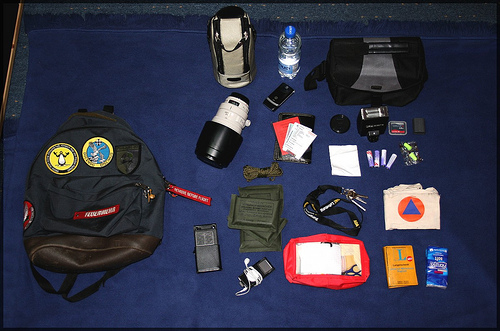<image>
Can you confirm if the water is above the ipod? No. The water is not positioned above the ipod. The vertical arrangement shows a different relationship. Is there a earplugs on the rug? Yes. Looking at the image, I can see the earplugs is positioned on top of the rug, with the rug providing support. 